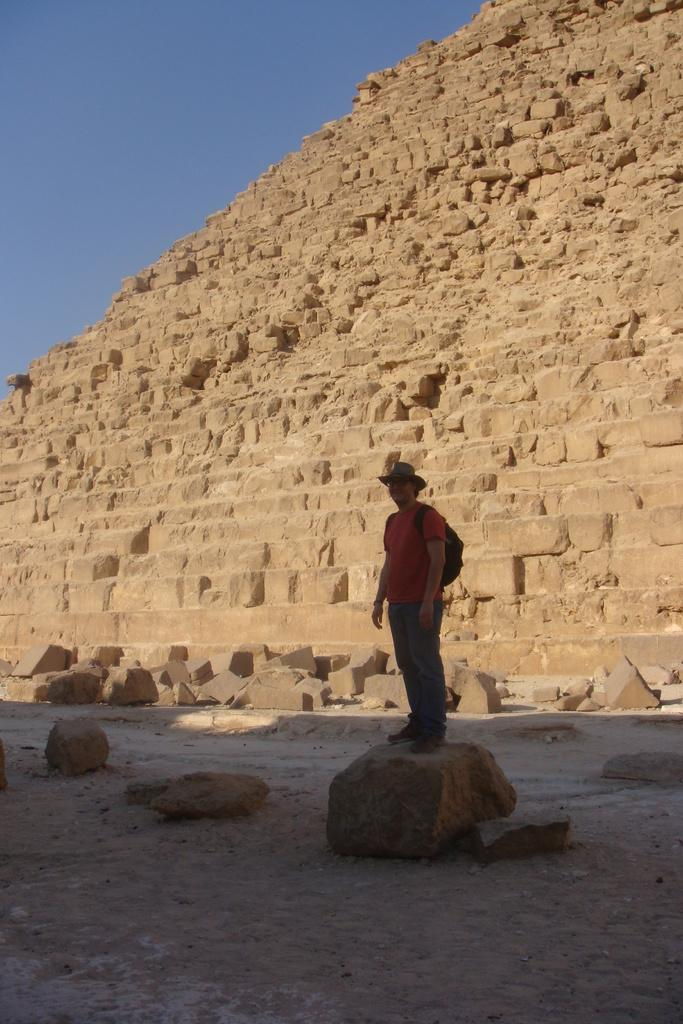What is the person in the image standing on? The person is standing on a stone. What can be seen in the background of the image? There is a stone structure and the sky visible in the background of the image. What is the ground made of in the image? The ground is made of sand at the bottom of the image. What type of lettuce is being used as a hat by the person in the image? There is no lettuce present in the image, and the person is not wearing a hat. 